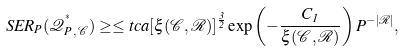<formula> <loc_0><loc_0><loc_500><loc_500>S E R _ { P } ( \mathcal { Q } _ { P \, , \, \mathcal { C } } ^ { ^ { * } } ) \geq \leq t c a [ \xi ( \mathcal { C } , \mathcal { R } ) ] ^ { \frac { 3 } { 2 } } \exp \left ( - \frac { C _ { 1 } } { \xi ( \mathcal { C } , \mathcal { R } ) } \right ) P ^ { - | \mathcal { R } | } ,</formula> 